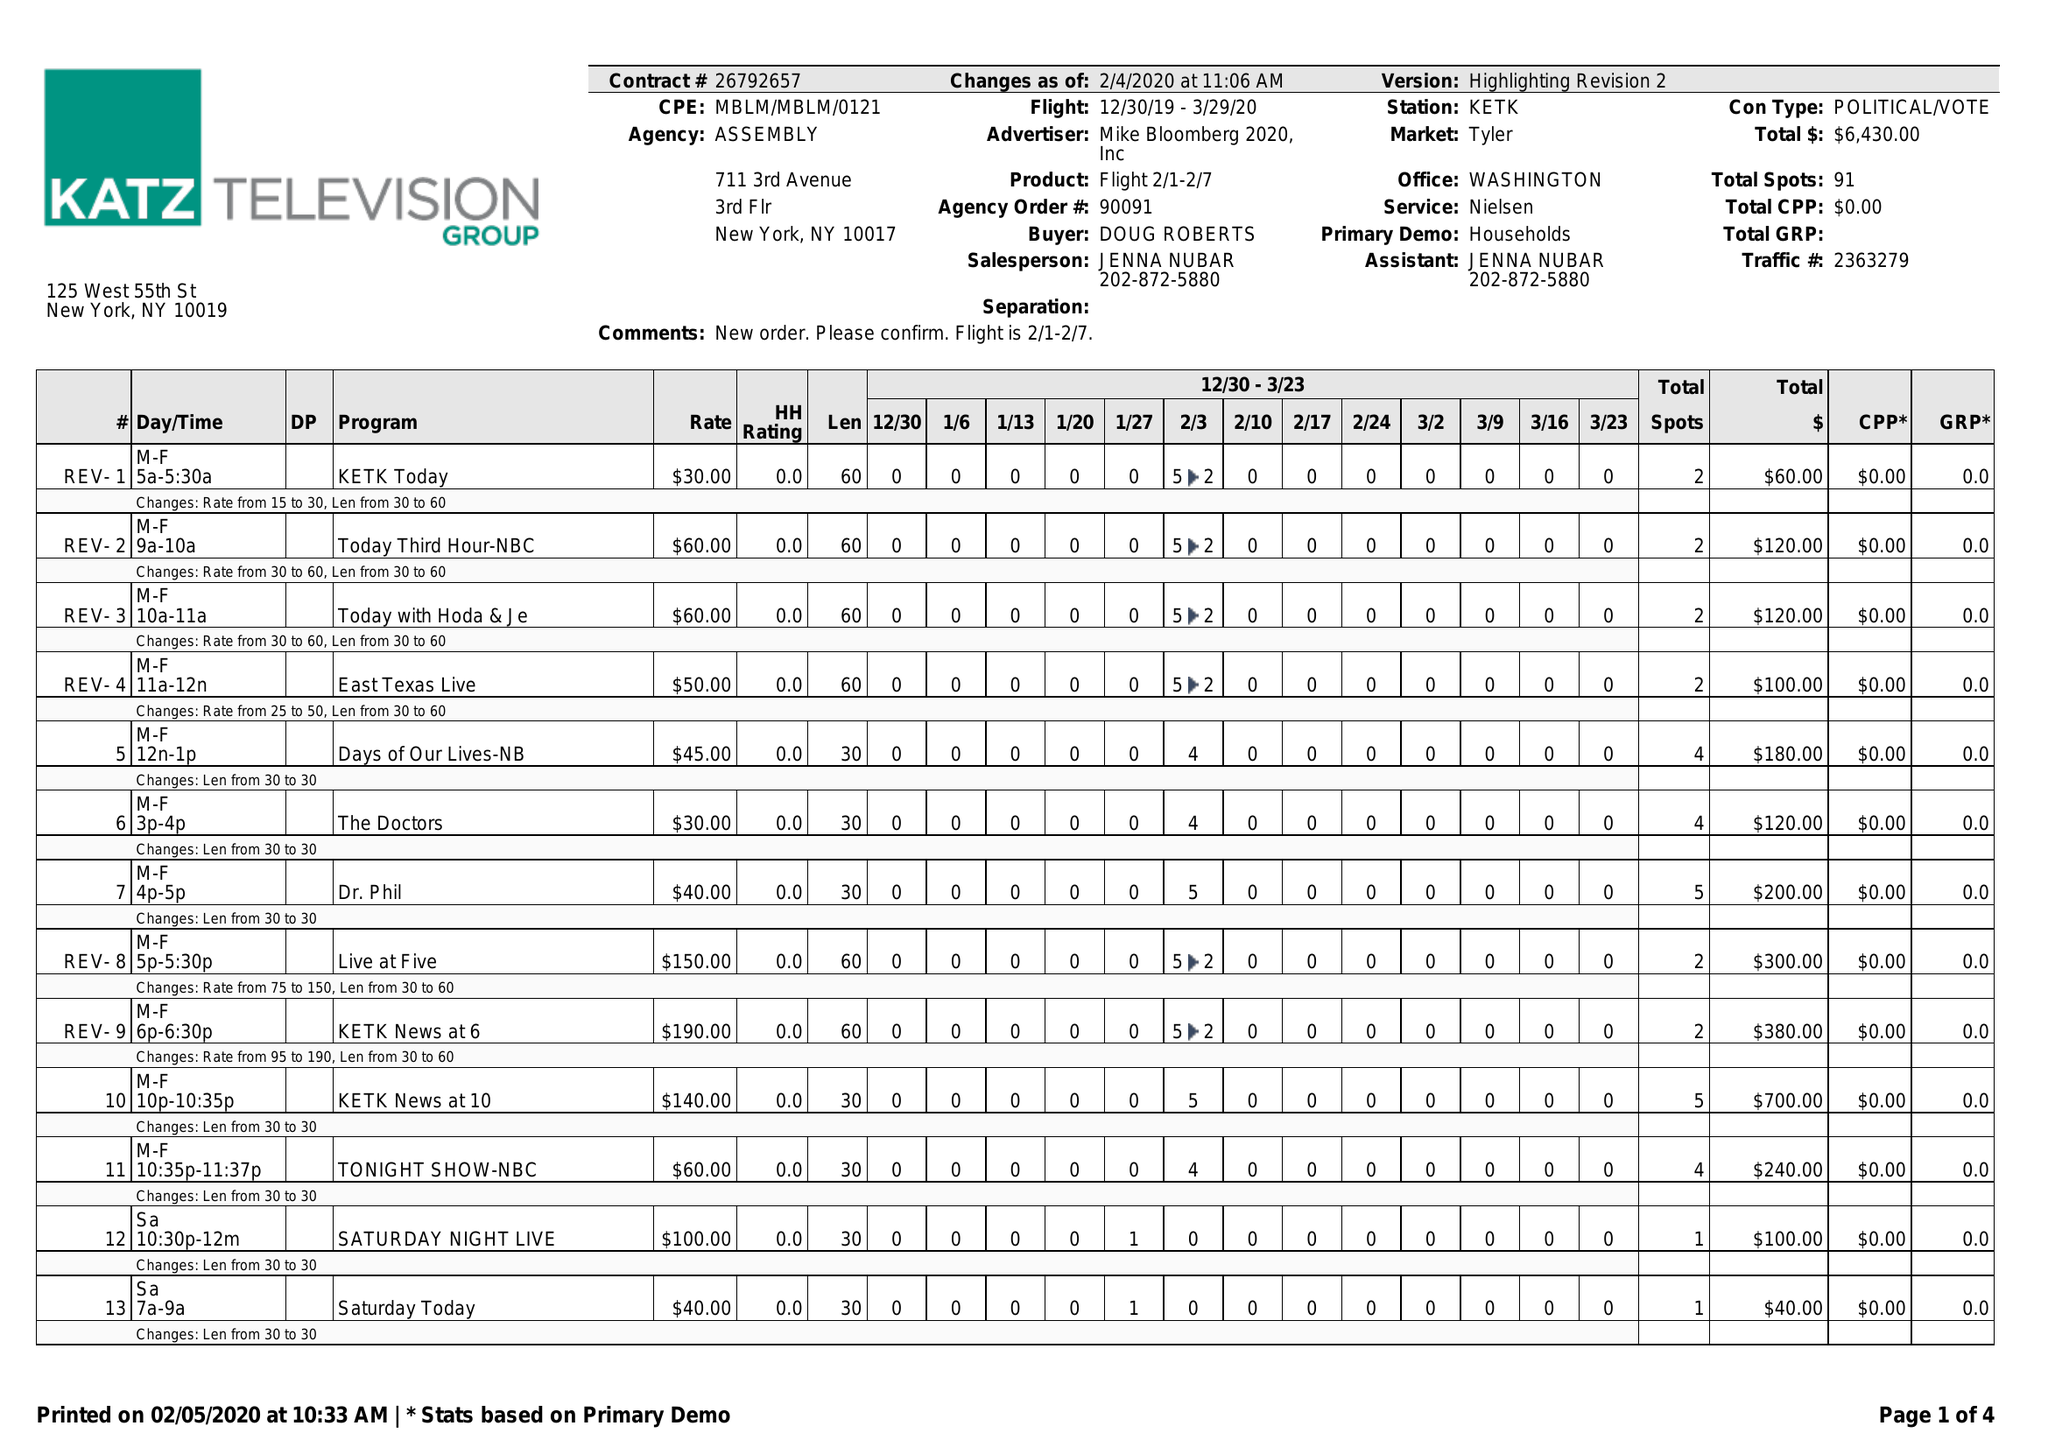What is the value for the advertiser?
Answer the question using a single word or phrase. MIKE BLOOMBERG 2020, INC 